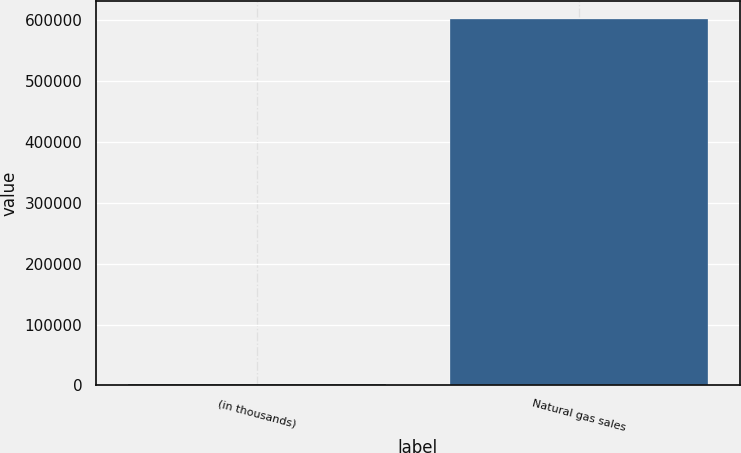Convert chart. <chart><loc_0><loc_0><loc_500><loc_500><bar_chart><fcel>(in thousands)<fcel>Natural gas sales<nl><fcel>2004<fcel>600806<nl></chart> 